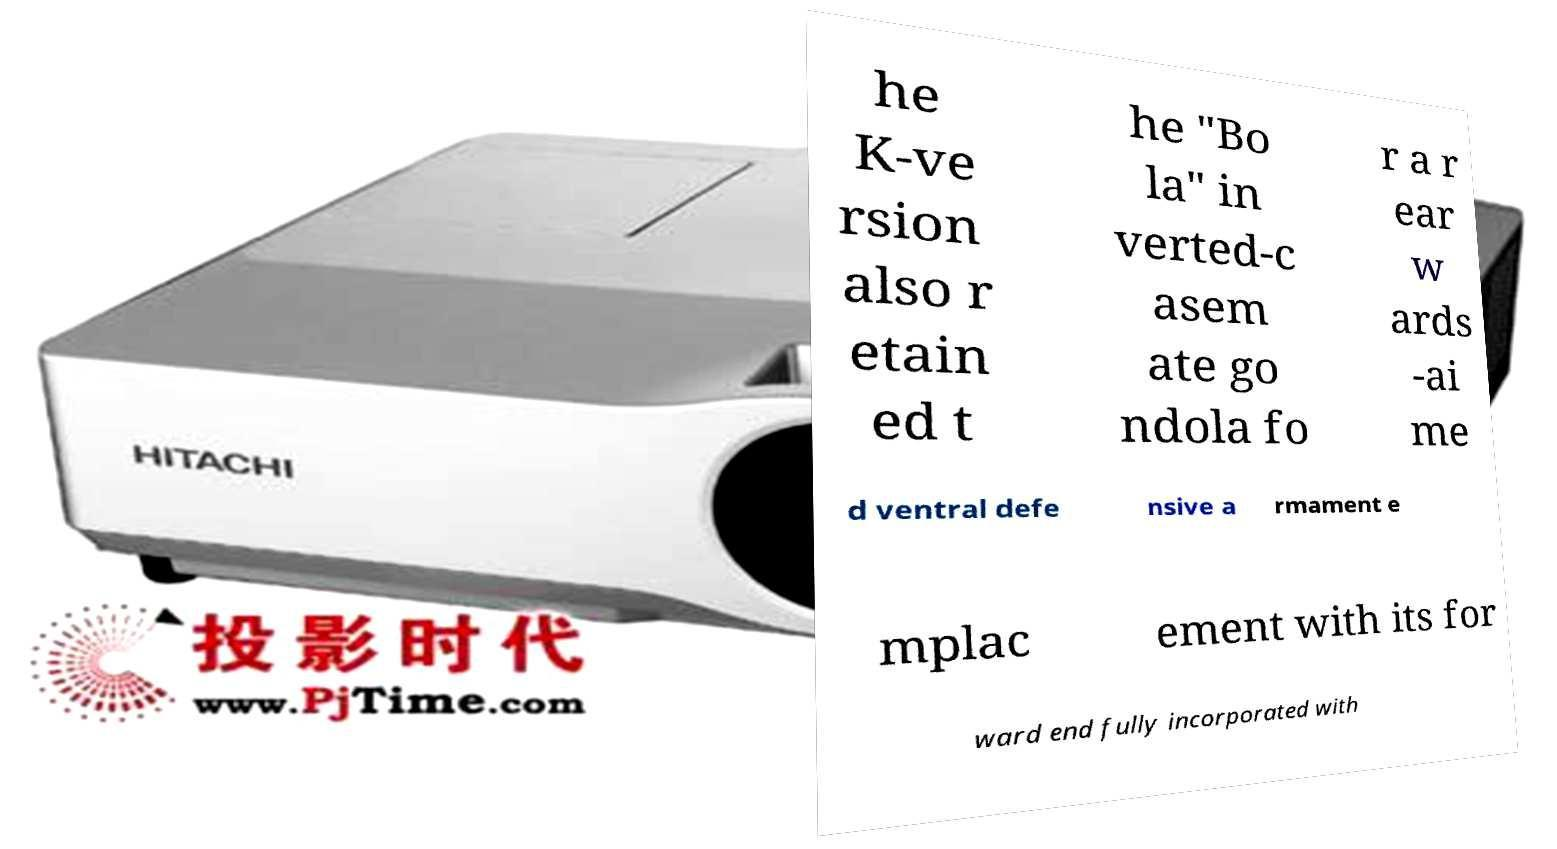There's text embedded in this image that I need extracted. Can you transcribe it verbatim? he K-ve rsion also r etain ed t he "Bo la" in verted-c asem ate go ndola fo r a r ear w ards -ai me d ventral defe nsive a rmament e mplac ement with its for ward end fully incorporated with 